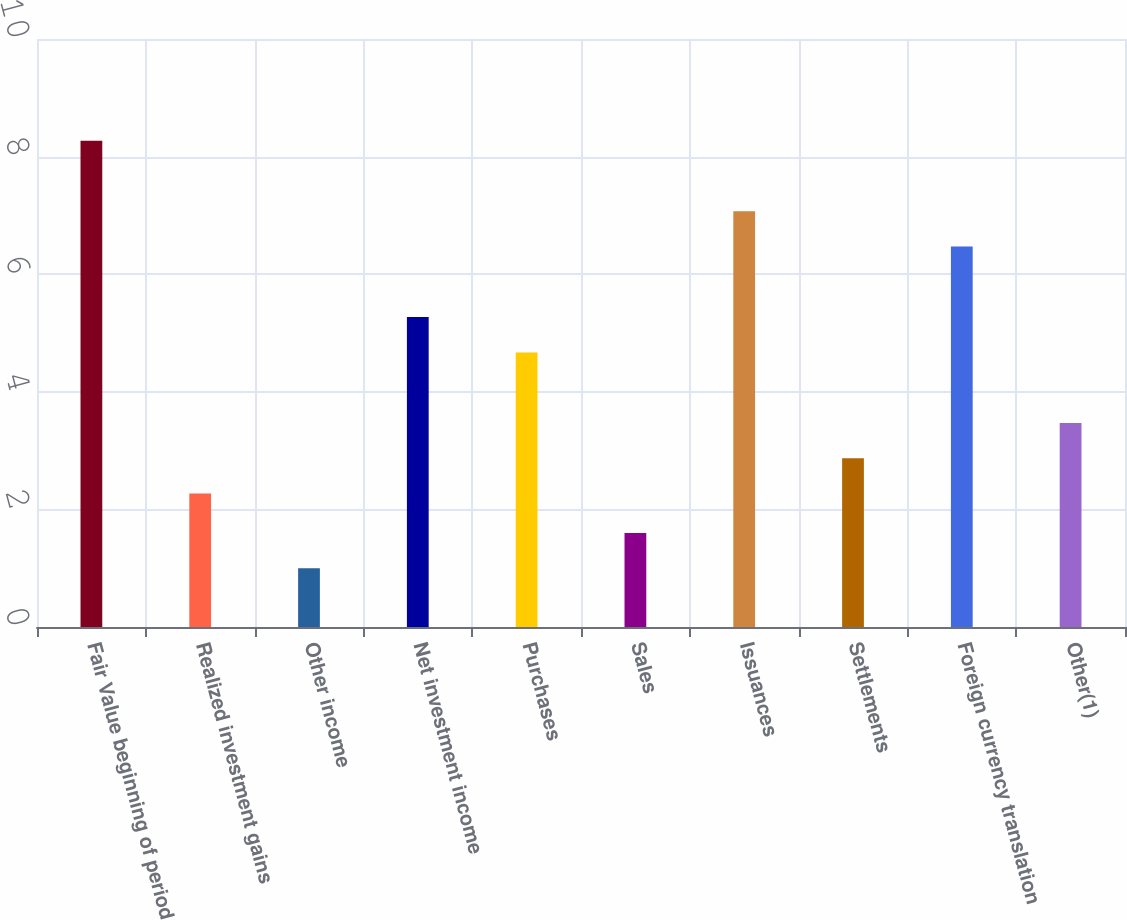Convert chart to OTSL. <chart><loc_0><loc_0><loc_500><loc_500><bar_chart><fcel>Fair Value beginning of period<fcel>Realized investment gains<fcel>Other income<fcel>Net investment income<fcel>Purchases<fcel>Sales<fcel>Issuances<fcel>Settlements<fcel>Foreign currency translation<fcel>Other(1)<nl><fcel>8.27<fcel>2.27<fcel>1<fcel>5.27<fcel>4.67<fcel>1.6<fcel>7.07<fcel>2.87<fcel>6.47<fcel>3.47<nl></chart> 